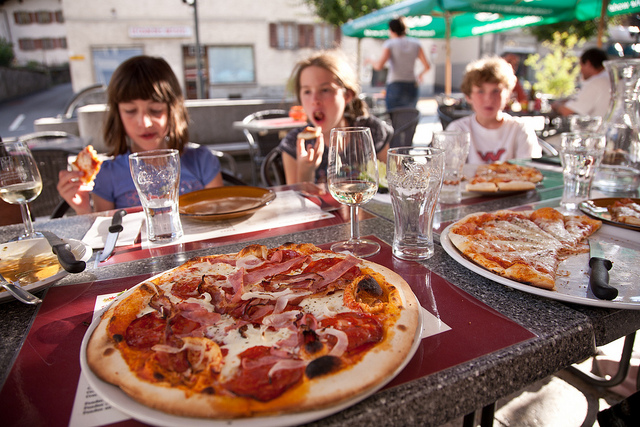<image>How many slices are on the closest plate? It is unknown how many slices are on the closest plate. How many slices are on the closest plate? I don't know how many slices are on the closest plate. It can be any number between 0 to 8. 